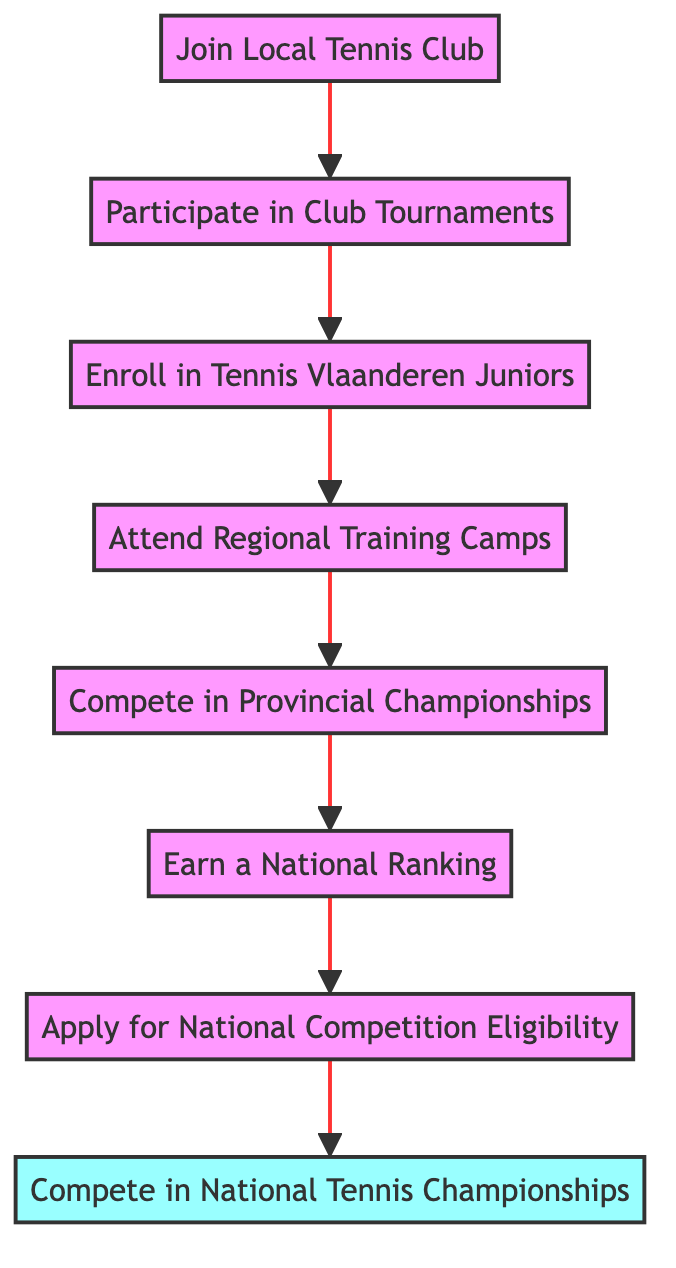What is the first step to enter national tennis competitions? The first step is identified at the bottom of the flow chart, which is to "Join Local Tennis Club." This is where the process begins.
Answer: Join Local Tennis Club How many total steps are there in the path to entering national tennis competitions? By counting the unique nodes in the flow chart, we see there are a total of 8 steps, starting from joining the local club to competing in national championships.
Answer: 8 What is the final goal in this flowchart? The final goal is at the top of the flowchart, which states "Compete in National Tennis Championships." This indicates the completion of the pathway.
Answer: Compete in National Tennis Championships Which step directly follows "Enroll in Tennis Vlaanderen Juniors"? By looking at the flow of the chart, "Enroll in Tennis Vlaanderen Juniors" is immediately followed by the step "Attend Regional Training Camps."
Answer: Attend Regional Training Camps What do you need to do after earning a national ranking? Following the "Earn a National Ranking" step in the flow chart, the next action is to "Apply for National Competition Eligibility." This shows the sequential nature of the pathway.
Answer: Apply for National Competition Eligibility How does "Compete in Provincial Championships" relate to "Participate in Club Tournaments"? "Compete in Provincial Championships" comes after "Participate in Club Tournaments." This shows that participating in club tournaments is a prerequisite to competing at the provincial level.
Answer: They are sequential steps What is the relationship between "Attend Regional Training Camps" and "Earn a National Ranking"? The flowchart indicates that "Attend Regional Training Camps" precedes "Earn a National Ranking." This establishes that improving skills through training camps is important before aiming for a national ranking.
Answer: Sequential relationship Which two steps must be completed before you can apply for national competition eligibility? Prior to applying for national competition eligibility, one must first "Earn a National Ranking" and "Compete in Provincial Championships." Both are necessary to fulfill the requirements for the application.
Answer: Earn a National Ranking and Compete in Provincial Championships 